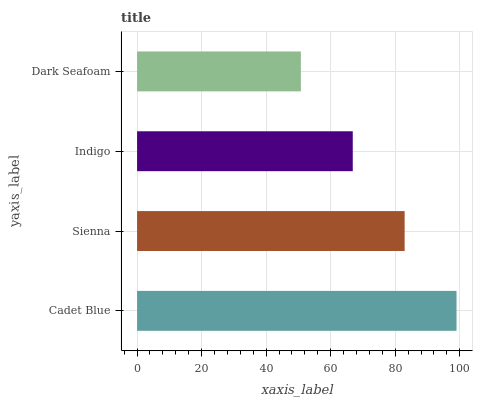Is Dark Seafoam the minimum?
Answer yes or no. Yes. Is Cadet Blue the maximum?
Answer yes or no. Yes. Is Sienna the minimum?
Answer yes or no. No. Is Sienna the maximum?
Answer yes or no. No. Is Cadet Blue greater than Sienna?
Answer yes or no. Yes. Is Sienna less than Cadet Blue?
Answer yes or no. Yes. Is Sienna greater than Cadet Blue?
Answer yes or no. No. Is Cadet Blue less than Sienna?
Answer yes or no. No. Is Sienna the high median?
Answer yes or no. Yes. Is Indigo the low median?
Answer yes or no. Yes. Is Cadet Blue the high median?
Answer yes or no. No. Is Dark Seafoam the low median?
Answer yes or no. No. 